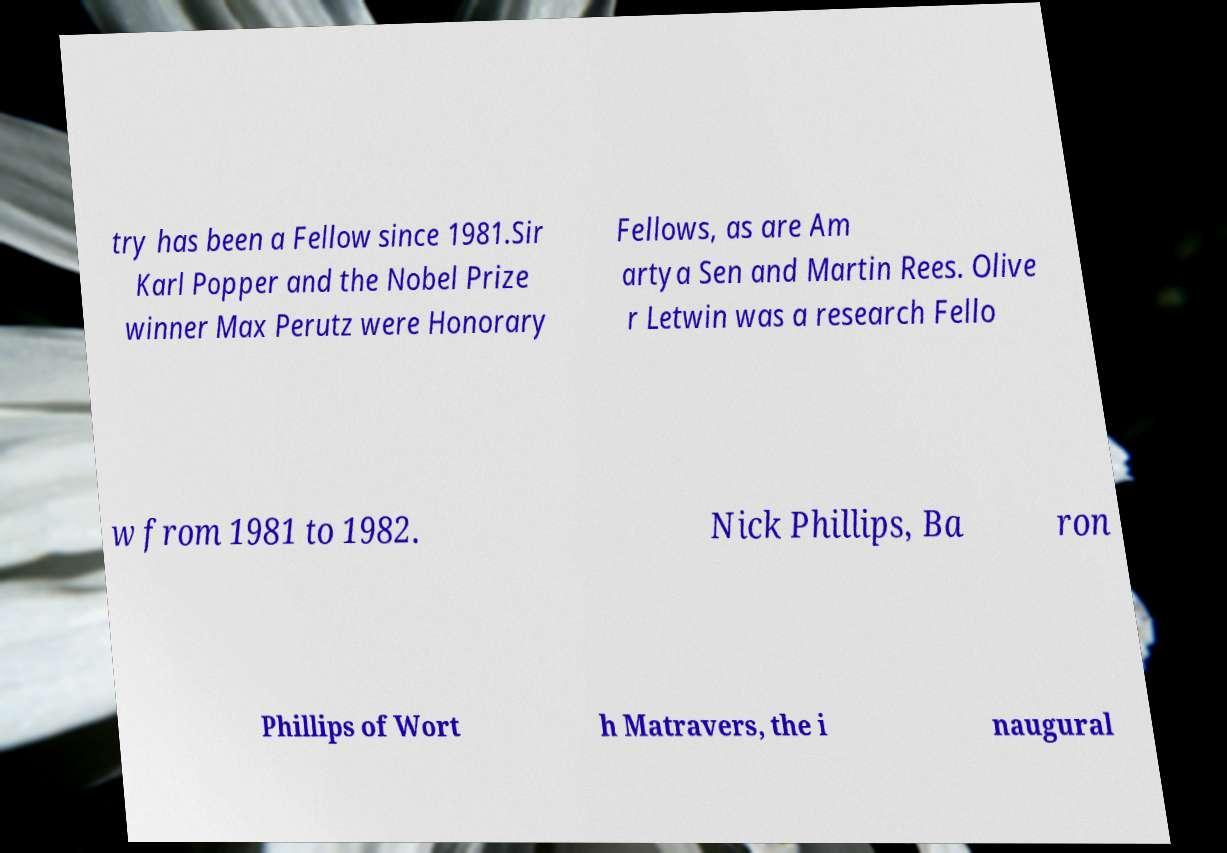There's text embedded in this image that I need extracted. Can you transcribe it verbatim? try has been a Fellow since 1981.Sir Karl Popper and the Nobel Prize winner Max Perutz were Honorary Fellows, as are Am artya Sen and Martin Rees. Olive r Letwin was a research Fello w from 1981 to 1982. Nick Phillips, Ba ron Phillips of Wort h Matravers, the i naugural 